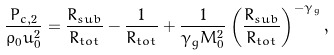Convert formula to latex. <formula><loc_0><loc_0><loc_500><loc_500>\frac { P _ { c , 2 } } { \rho _ { 0 } u _ { 0 } ^ { 2 } } = \frac { R _ { s u b } } { R _ { t o t } } - \frac { 1 } { R _ { t o t } } + \frac { 1 } { \gamma _ { g } M _ { 0 } ^ { 2 } } \left ( \frac { R _ { s u b } } { R _ { t o t } } \right ) ^ { - \gamma _ { g } } ,</formula> 